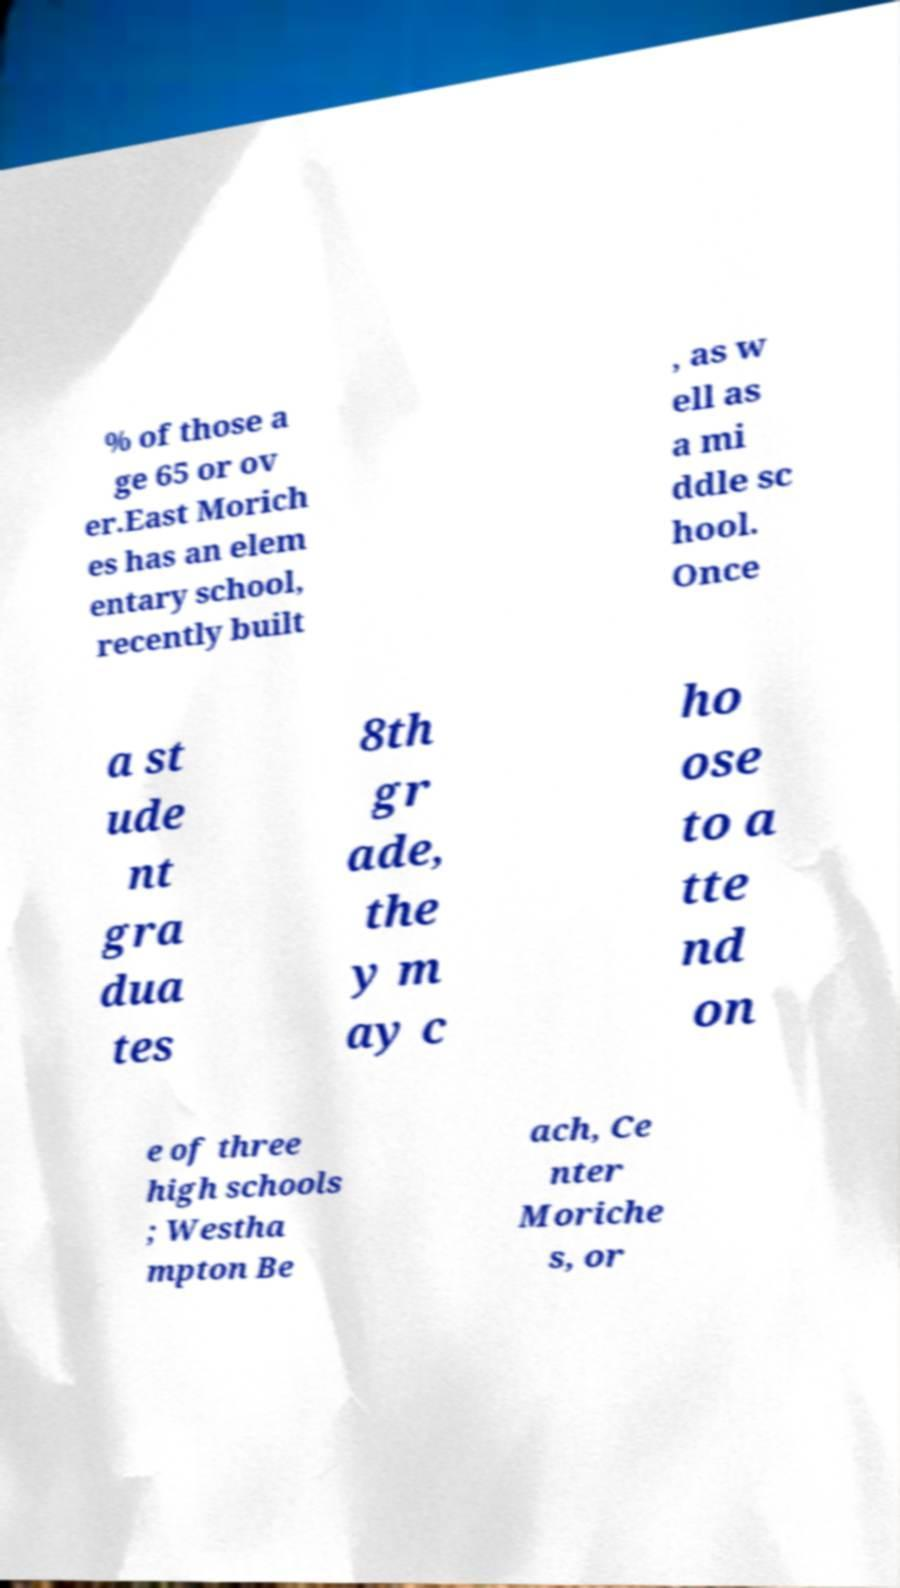For documentation purposes, I need the text within this image transcribed. Could you provide that? % of those a ge 65 or ov er.East Morich es has an elem entary school, recently built , as w ell as a mi ddle sc hool. Once a st ude nt gra dua tes 8th gr ade, the y m ay c ho ose to a tte nd on e of three high schools ; Westha mpton Be ach, Ce nter Moriche s, or 